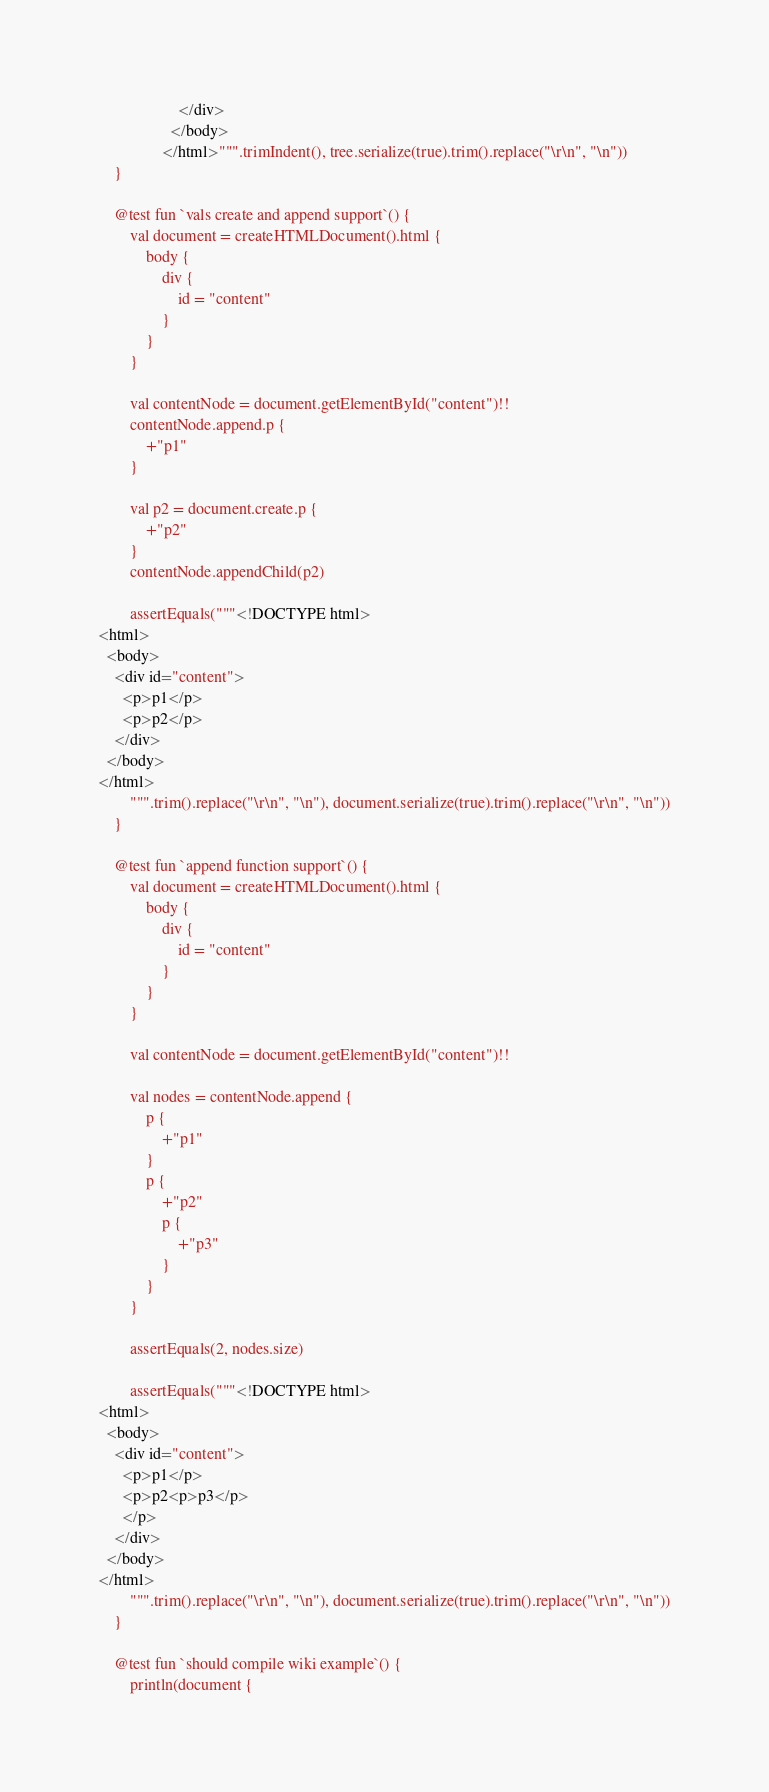<code> <loc_0><loc_0><loc_500><loc_500><_Kotlin_>                    </div>
                  </body>
                </html>""".trimIndent(), tree.serialize(true).trim().replace("\r\n", "\n"))
    }

    @test fun `vals create and append support`() {
        val document = createHTMLDocument().html {
            body {
                div {
                    id = "content"
                }
            }
        }

        val contentNode = document.getElementById("content")!!
        contentNode.append.p {
            +"p1"
        }

        val p2 = document.create.p {
            +"p2"
        }
        contentNode.appendChild(p2)

        assertEquals("""<!DOCTYPE html>
<html>
  <body>
    <div id="content">
      <p>p1</p>
      <p>p2</p>
    </div>
  </body>
</html>
        """.trim().replace("\r\n", "\n"), document.serialize(true).trim().replace("\r\n", "\n"))
    }

    @test fun `append function support`() {
        val document = createHTMLDocument().html {
            body {
                div {
                    id = "content"
                }
            }
        }

        val contentNode = document.getElementById("content")!!

        val nodes = contentNode.append {
            p {
                +"p1"
            }
            p {
                +"p2"
                p {
                    +"p3"
                }
            }
        }

        assertEquals(2, nodes.size)

        assertEquals("""<!DOCTYPE html>
<html>
  <body>
    <div id="content">
      <p>p1</p>
      <p>p2<p>p3</p>
      </p>
    </div>
  </body>
</html>
        """.trim().replace("\r\n", "\n"), document.serialize(true).trim().replace("\r\n", "\n"))
    }

    @test fun `should compile wiki example`() {
        println(document {</code> 